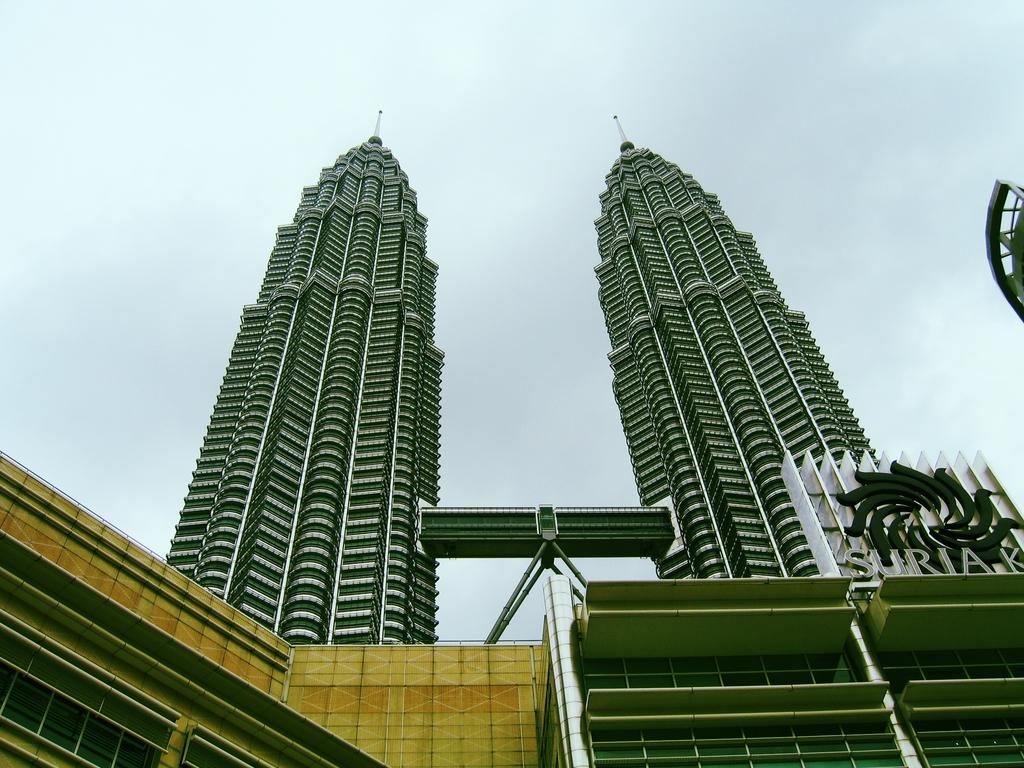What type of structures can be seen in the image? There are buildings in the image. What additional feature is present in the image? There is a banner in the image. What is visible at the top of the image? The sky is visible at the top of the image. What degree does the person in jail have in the image? There is no person in jail and no mention of a degree in the image. 